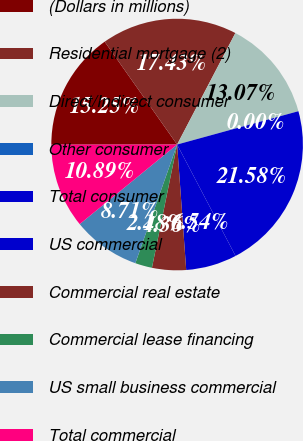Convert chart. <chart><loc_0><loc_0><loc_500><loc_500><pie_chart><fcel>(Dollars in millions)<fcel>Residential mortgage (2)<fcel>Direct/Indirect consumer<fcel>Other consumer<fcel>Total consumer<fcel>US commercial<fcel>Commercial real estate<fcel>Commercial lease financing<fcel>US small business commercial<fcel>Total commercial<nl><fcel>15.25%<fcel>17.43%<fcel>13.07%<fcel>0.0%<fcel>21.58%<fcel>6.54%<fcel>4.36%<fcel>2.18%<fcel>8.71%<fcel>10.89%<nl></chart> 